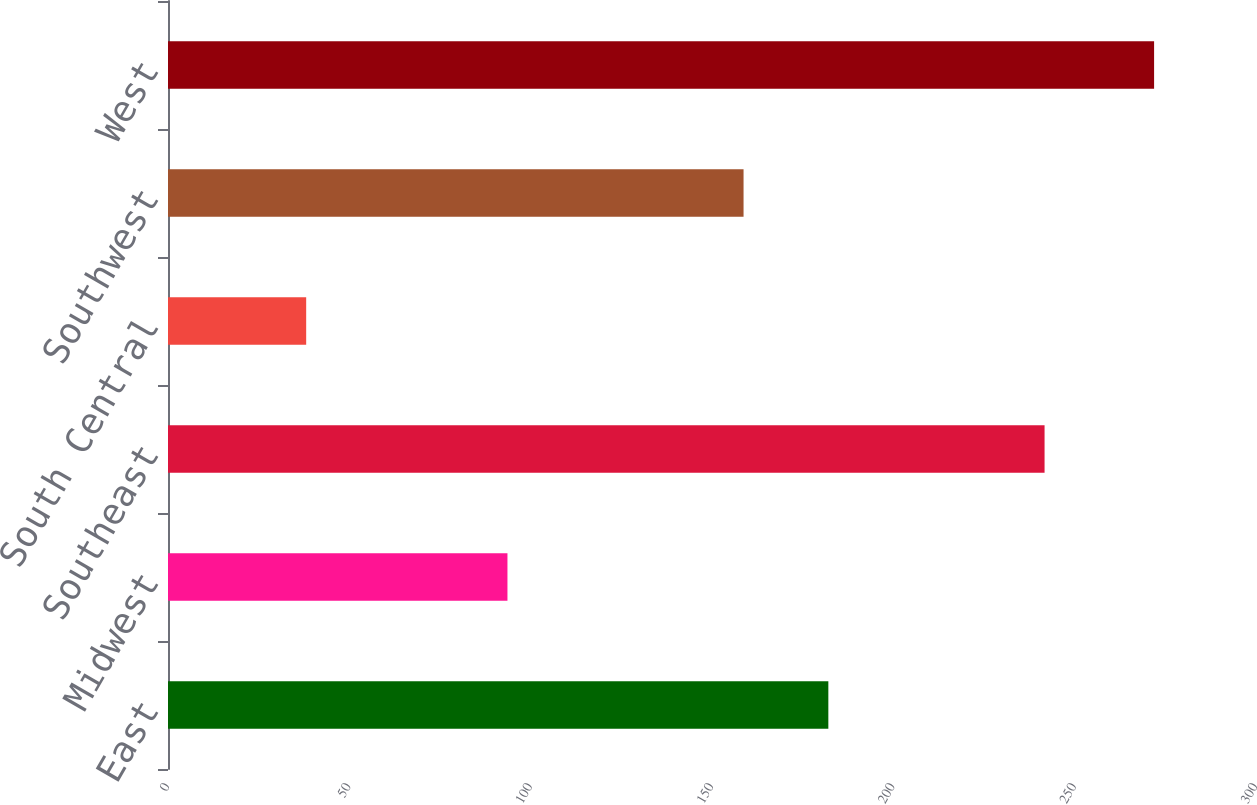Convert chart. <chart><loc_0><loc_0><loc_500><loc_500><bar_chart><fcel>East<fcel>Midwest<fcel>Southeast<fcel>South Central<fcel>Southwest<fcel>West<nl><fcel>182.08<fcel>93.6<fcel>241.7<fcel>38.1<fcel>158.7<fcel>271.9<nl></chart> 